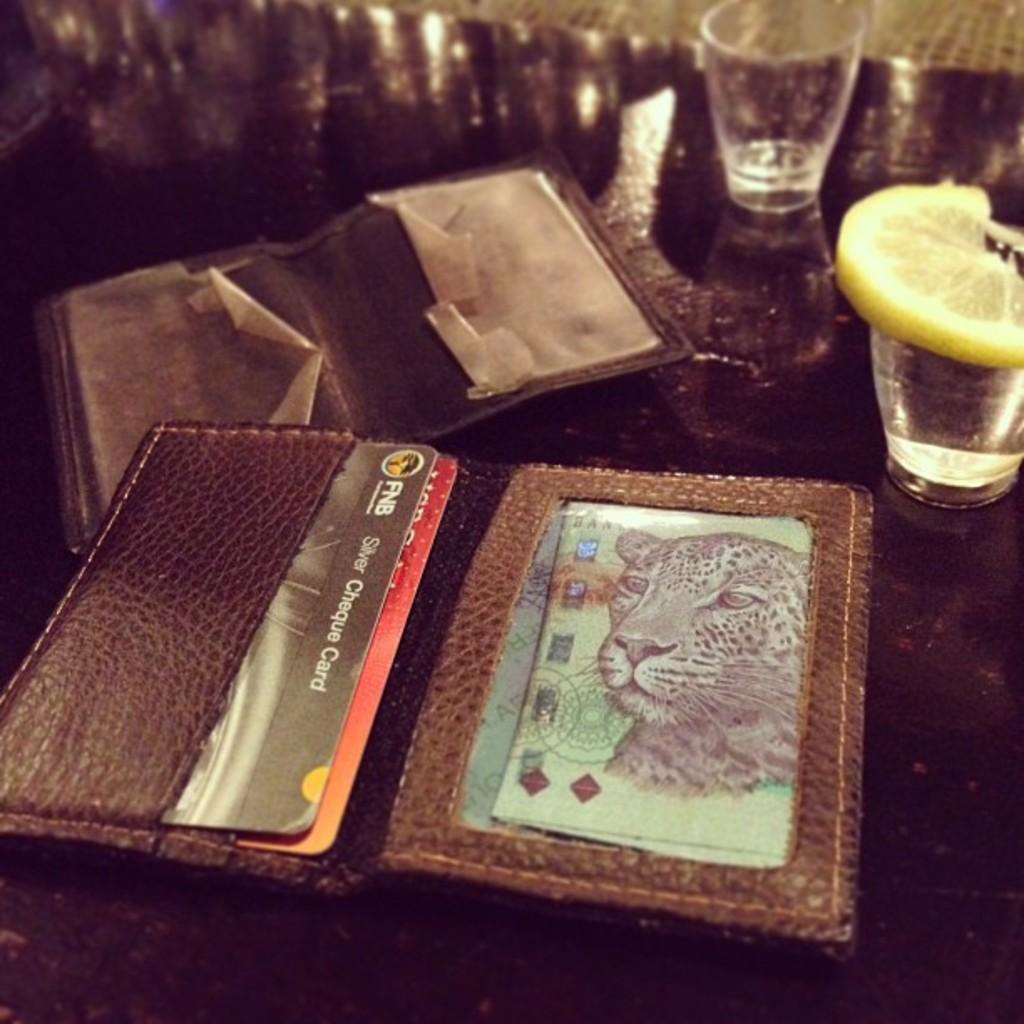What kind of card is on the left?
Keep it short and to the point. Cheque card. 